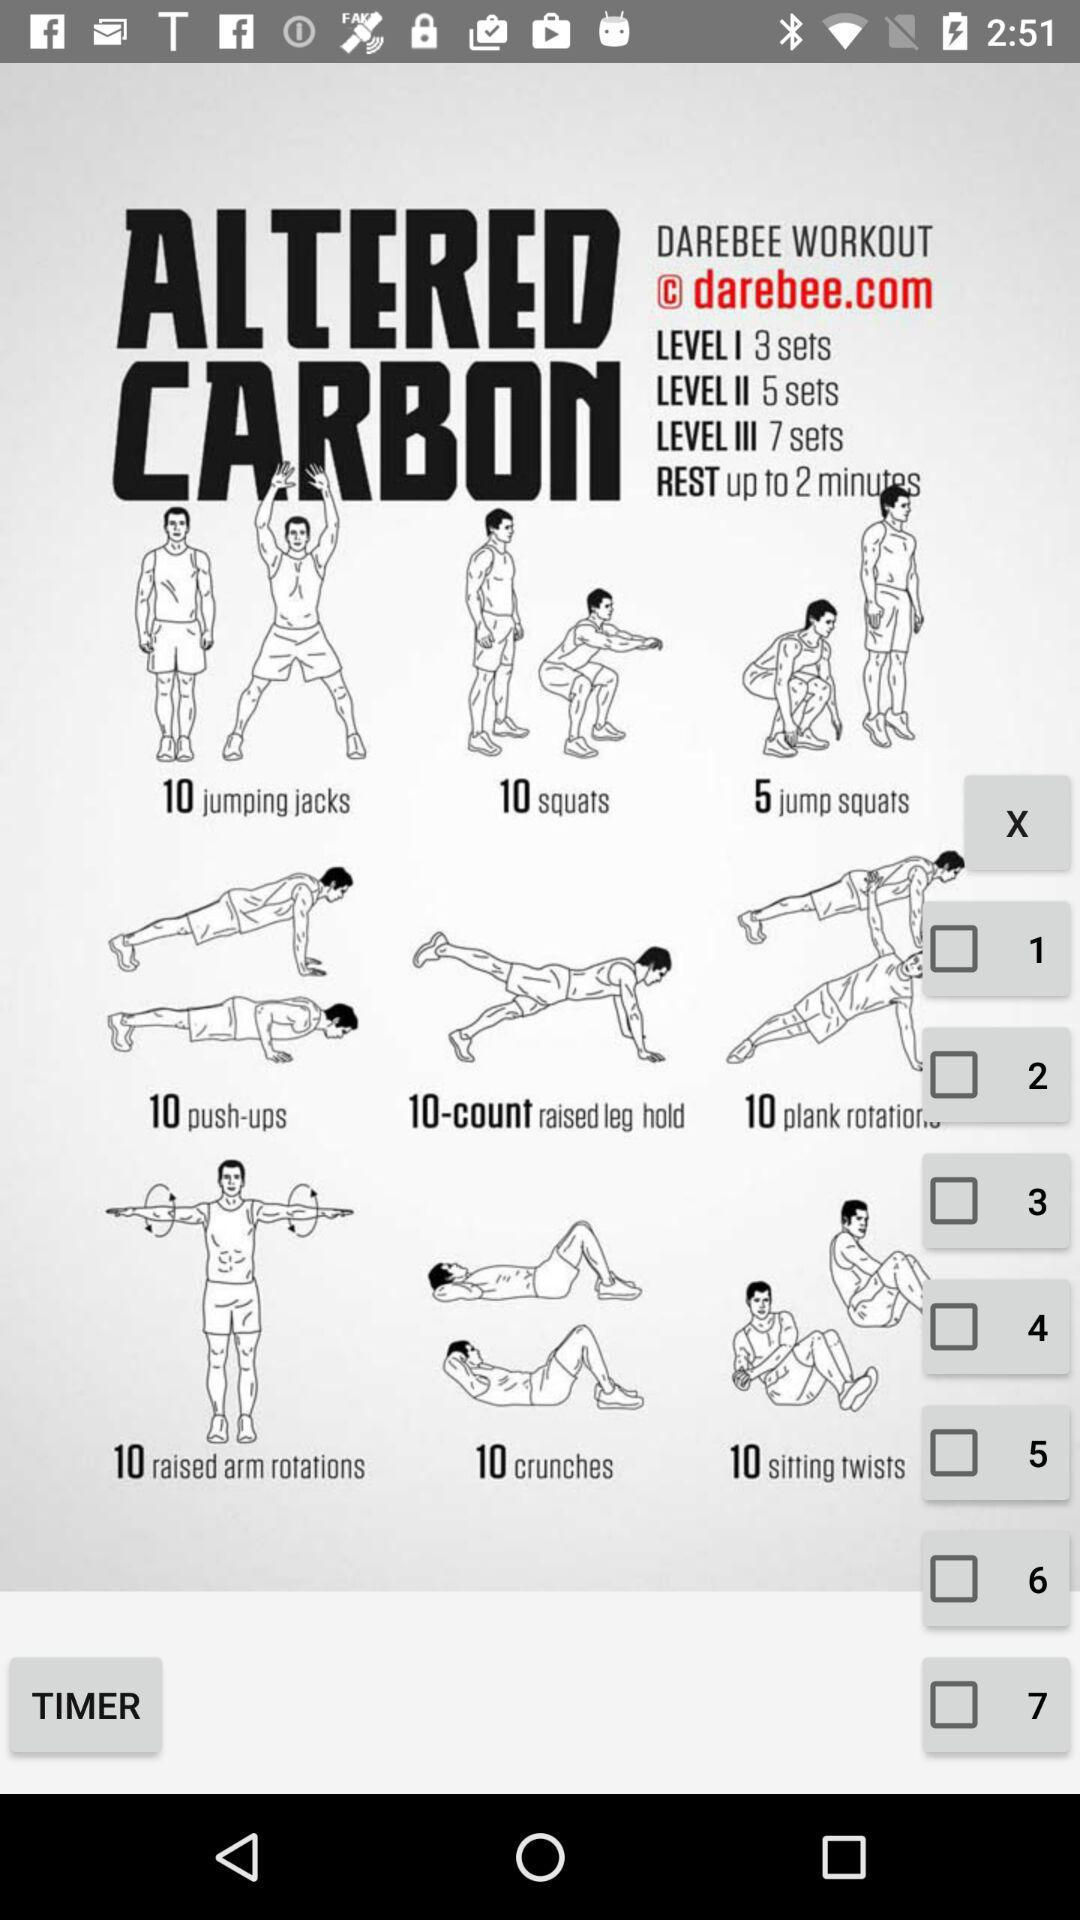How many sets are there in Level III?
Answer the question using a single word or phrase. 7 